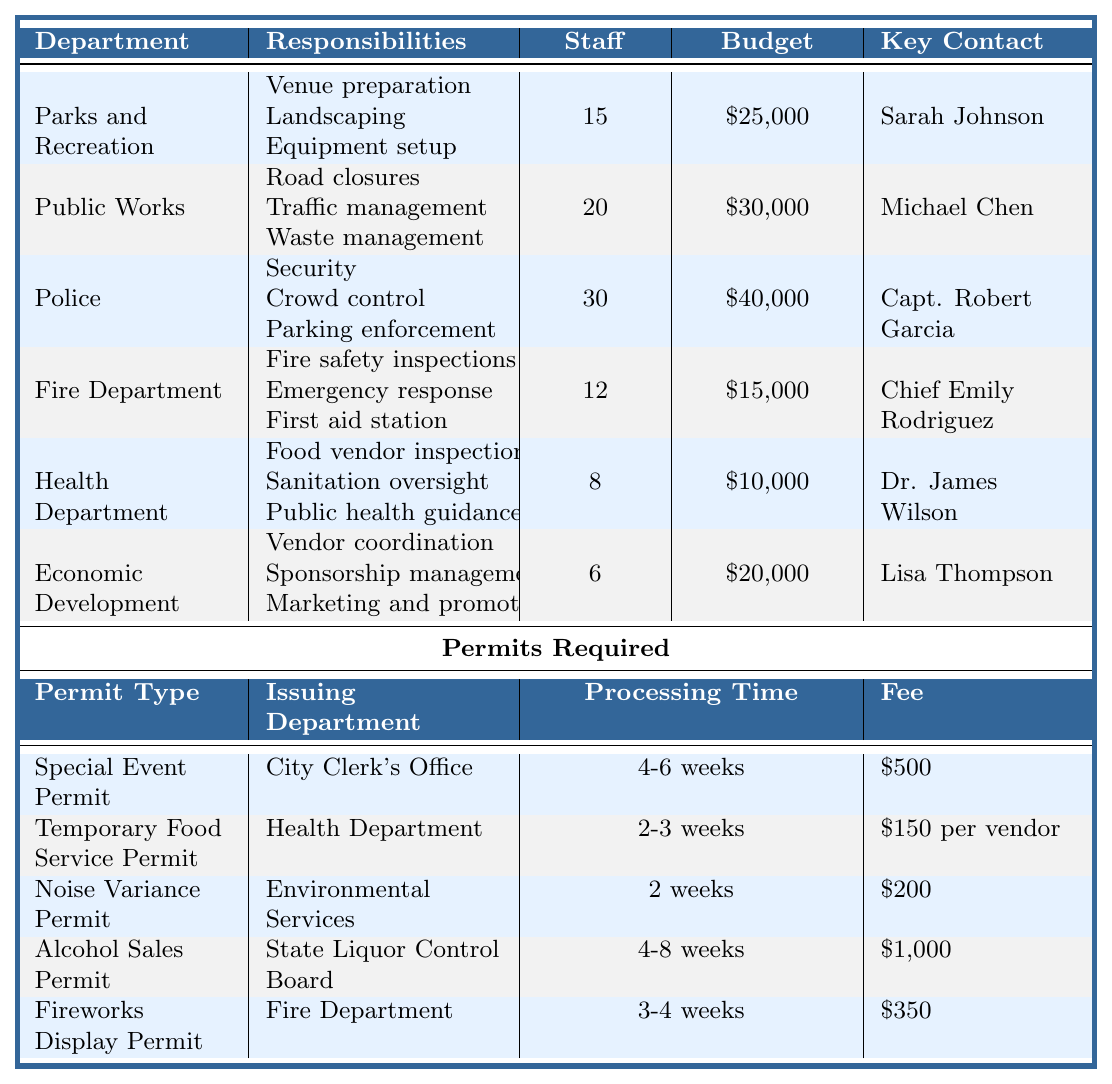What is the total budget allocated for the Parks and Recreation and Public Works departments? The budget for Parks and Recreation is $25,000 and for Public Works is $30,000. Summing these amounts gives $25,000 + $30,000 = $55,000.
Answer: $55,000 Who is the key contact for the Health Department? The key contact for the Health Department is listed as Dr. James Wilson.
Answer: Dr. James Wilson How many staff are involved in total for all the departments listed? The staff numbers for each department are: Parks and Recreation (15), Public Works (20), Police (30), Fire Department (12), Health Department (8), and Economic Development (6). Summing these gives: 15 + 20 + 30 + 12 + 8 + 6 = 91.
Answer: 91 Does the Economic Development department have a higher budget than the Fire Department? The budget for Economic Development is $20,000, while the Fire Department's budget is $15,000. Since $20,000 > $15,000, the statement is true.
Answer: Yes What is the processing time for a Temporary Food Service Permit? The processing time for the Temporary Food Service Permit is listed as 2-3 weeks.
Answer: 2-3 weeks Which department is responsible for issuing the Alcohol Sales Permit? The Alcohol Sales Permit is issued by the State Liquor Control Board.
Answer: State Liquor Control Board What is the total number of staff involved in the Police and Fire Department combined? The Police department has 30 staff, and the Fire Department has 12 staff. Adding these gives: 30 + 12 = 42 staff.
Answer: 42 Is the budget allocated to the Police department the highest among all departments? The budget for the Police department is $40,000, which is higher than Parks and Recreation ($25,000), Public Works ($30,000), Fire Department ($15,000), Health Department ($10,000), and Economic Development ($20,000). Hence, it is the highest.
Answer: Yes How much does it cost for a temporary food service vendor permit? The fee for the Temporary Food Service Permit is specified as $150 per vendor.
Answer: $150 per vendor What are the responsibilities of the Fire Department? The Fire Department's responsibilities include fire safety inspections, emergency response, and providing a first aid station.
Answer: Fire safety inspections, emergency response, first aid station Which department has the least number of staff involved? The Economic Development department has 6 staff involved, which is fewer than all other departments listed.
Answer: Economic Development 